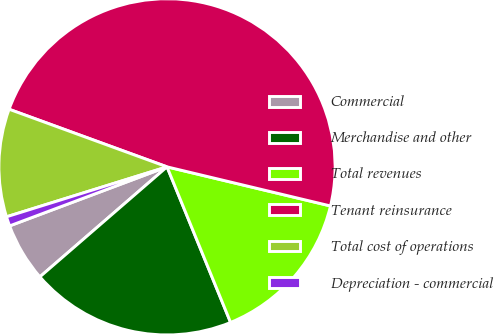Convert chart to OTSL. <chart><loc_0><loc_0><loc_500><loc_500><pie_chart><fcel>Commercial<fcel>Merchandise and other<fcel>Total revenues<fcel>Tenant reinsurance<fcel>Total cost of operations<fcel>Depreciation - commercial<nl><fcel>5.64%<fcel>19.82%<fcel>15.09%<fcel>48.17%<fcel>10.37%<fcel>0.91%<nl></chart> 